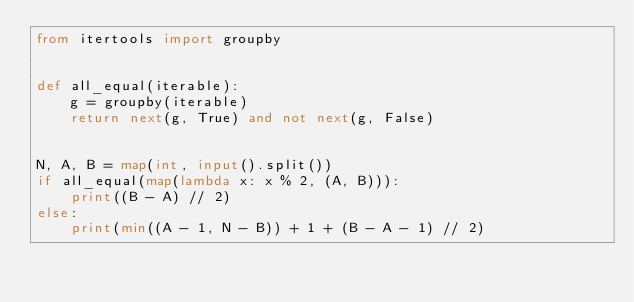Convert code to text. <code><loc_0><loc_0><loc_500><loc_500><_Python_>from itertools import groupby


def all_equal(iterable):
    g = groupby(iterable)
    return next(g, True) and not next(g, False)


N, A, B = map(int, input().split())
if all_equal(map(lambda x: x % 2, (A, B))):
    print((B - A) // 2)
else:
    print(min((A - 1, N - B)) + 1 + (B - A - 1) // 2)
</code> 